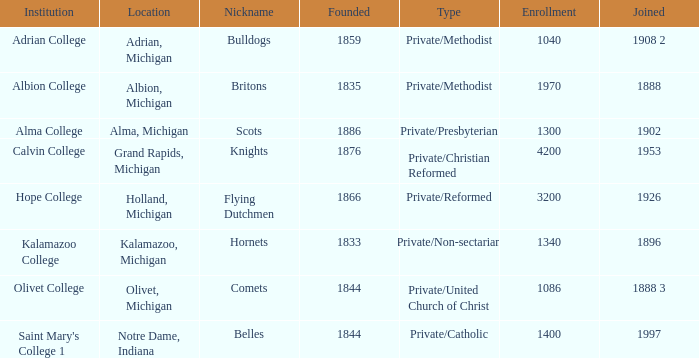Under charming elements, which has the highest probability of being created? 1844.0. 